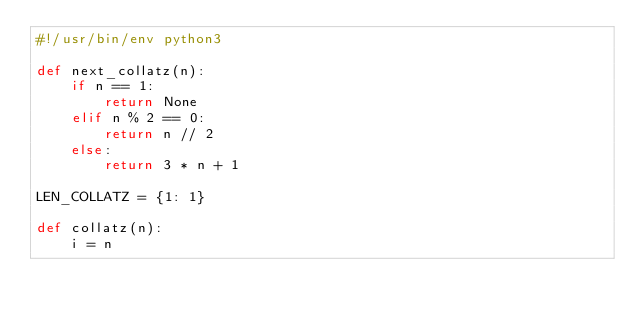Convert code to text. <code><loc_0><loc_0><loc_500><loc_500><_Python_>#!/usr/bin/env python3

def next_collatz(n):
    if n == 1:
        return None
    elif n % 2 == 0:
        return n // 2
    else:
        return 3 * n + 1

LEN_COLLATZ = {1: 1}

def collatz(n):
    i = n</code> 